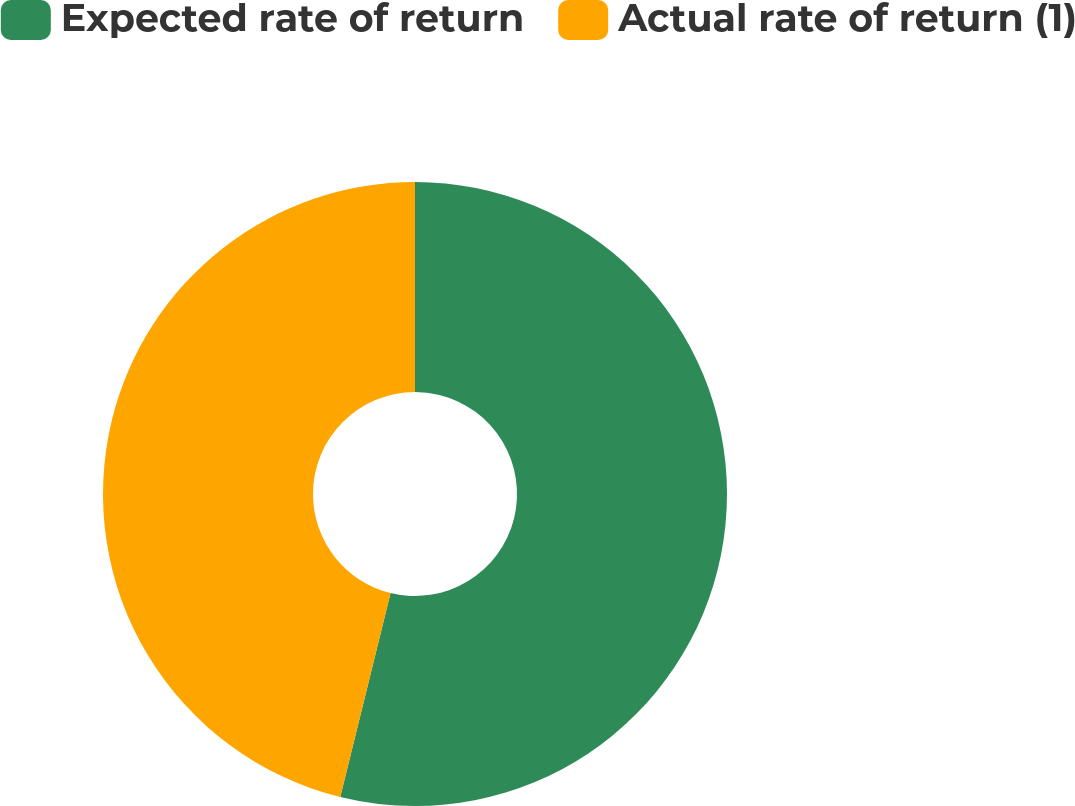Convert chart. <chart><loc_0><loc_0><loc_500><loc_500><pie_chart><fcel>Expected rate of return<fcel>Actual rate of return (1)<nl><fcel>53.85%<fcel>46.15%<nl></chart> 